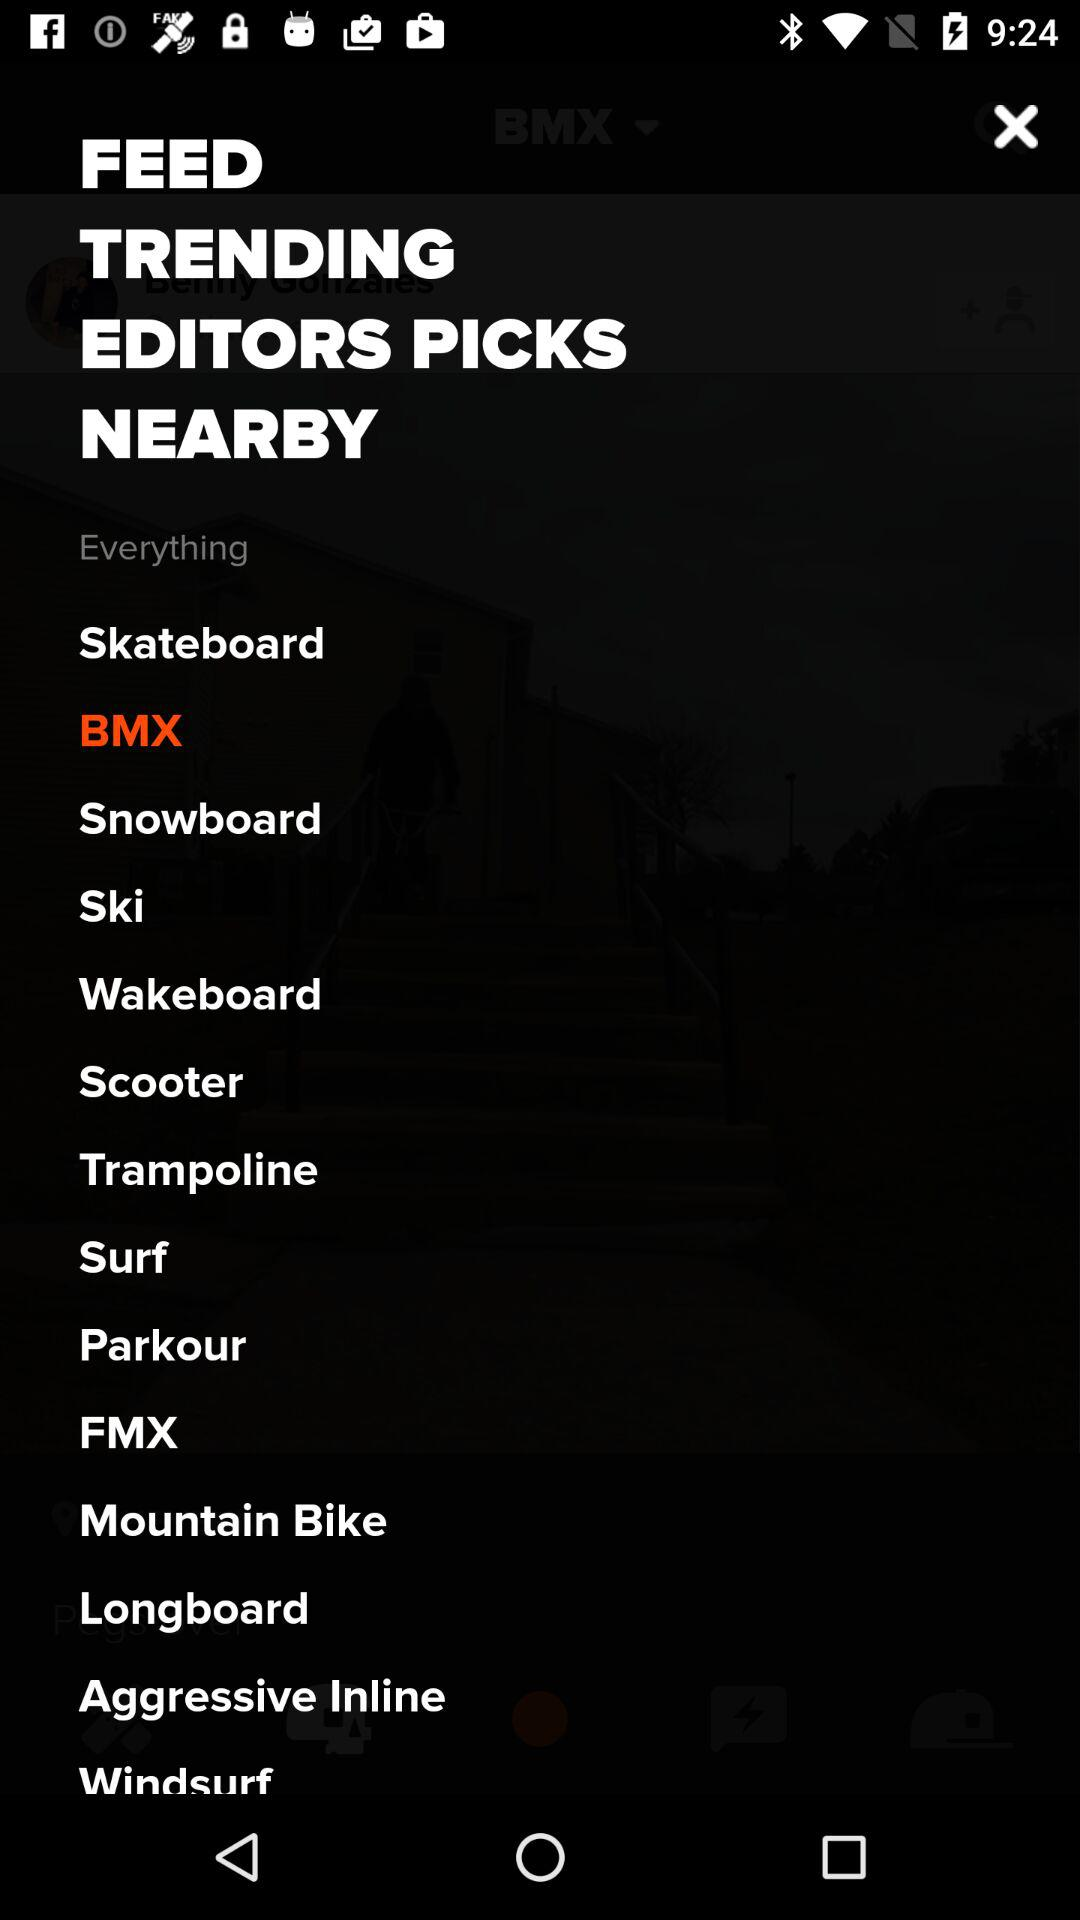Which option is selected? The selected option is "BMX". 